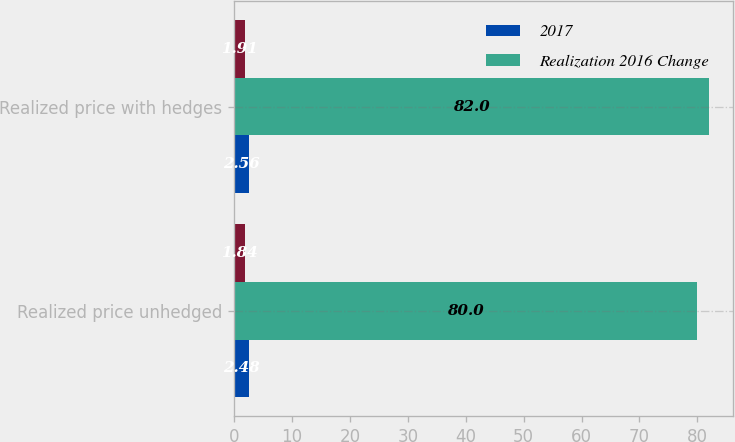Convert chart to OTSL. <chart><loc_0><loc_0><loc_500><loc_500><stacked_bar_chart><ecel><fcel>Realized price unhedged<fcel>Realized price with hedges<nl><fcel>2017<fcel>2.48<fcel>2.56<nl><fcel>Realization 2016 Change<fcel>80<fcel>82<nl><fcel>nan<fcel>1.84<fcel>1.91<nl></chart> 